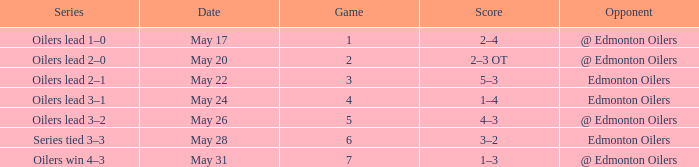Series of oilers win 4–3 had what highest game? 7.0. 